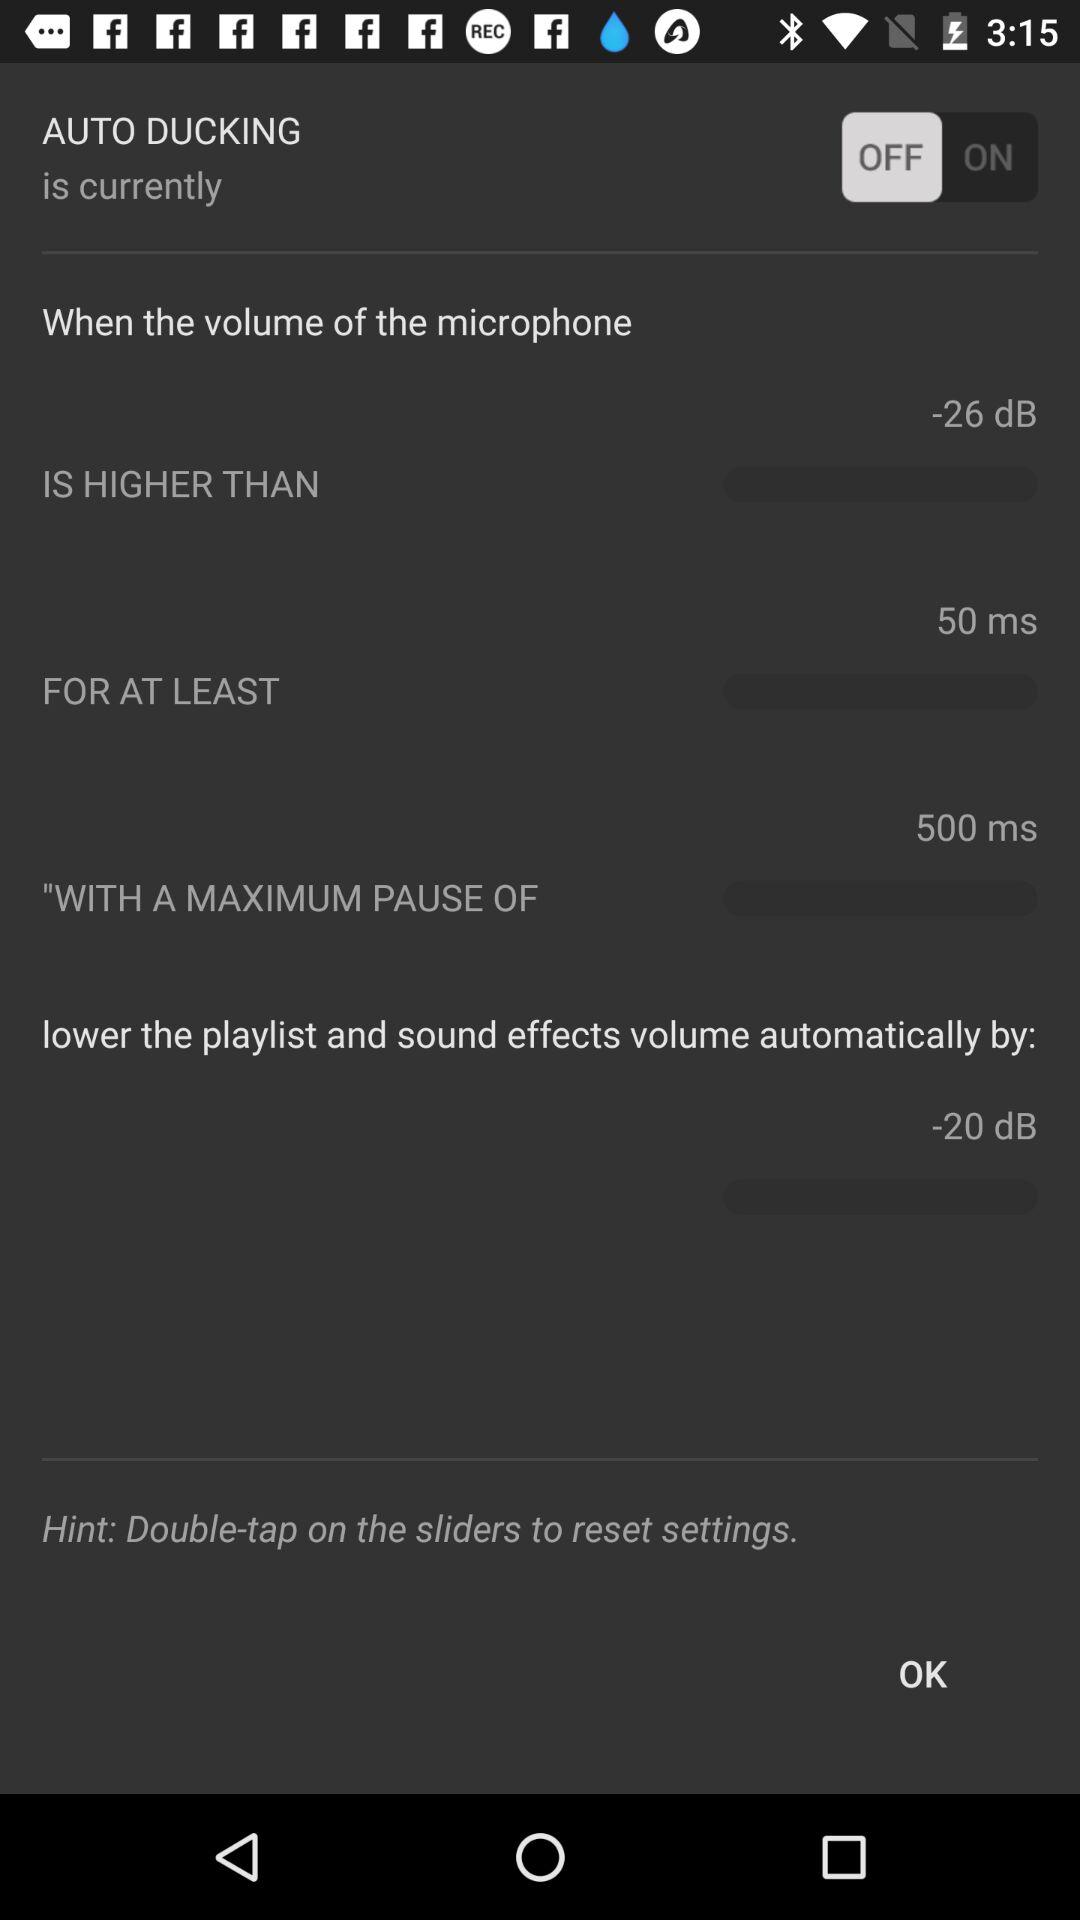What is the instruction to reset settings? The instruction to reset settings is "Double-tap on the sliders". 